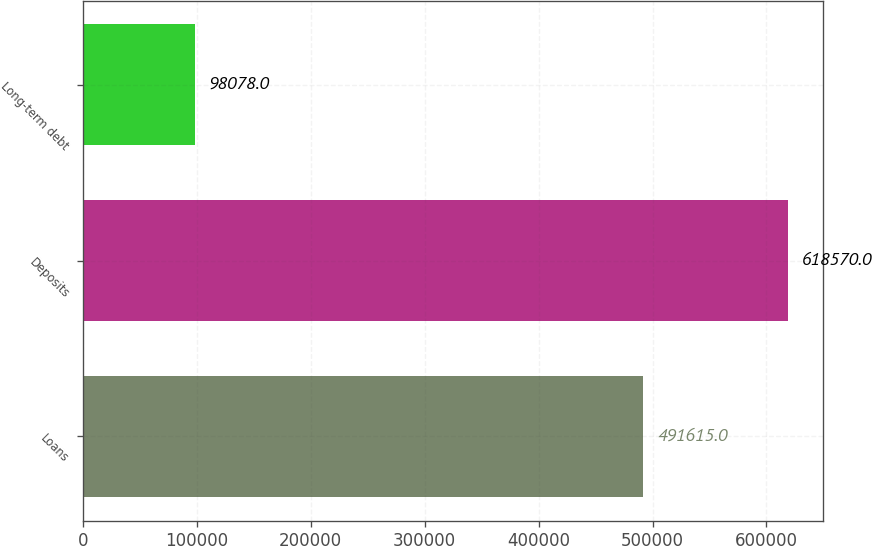Convert chart to OTSL. <chart><loc_0><loc_0><loc_500><loc_500><bar_chart><fcel>Loans<fcel>Deposits<fcel>Long-term debt<nl><fcel>491615<fcel>618570<fcel>98078<nl></chart> 